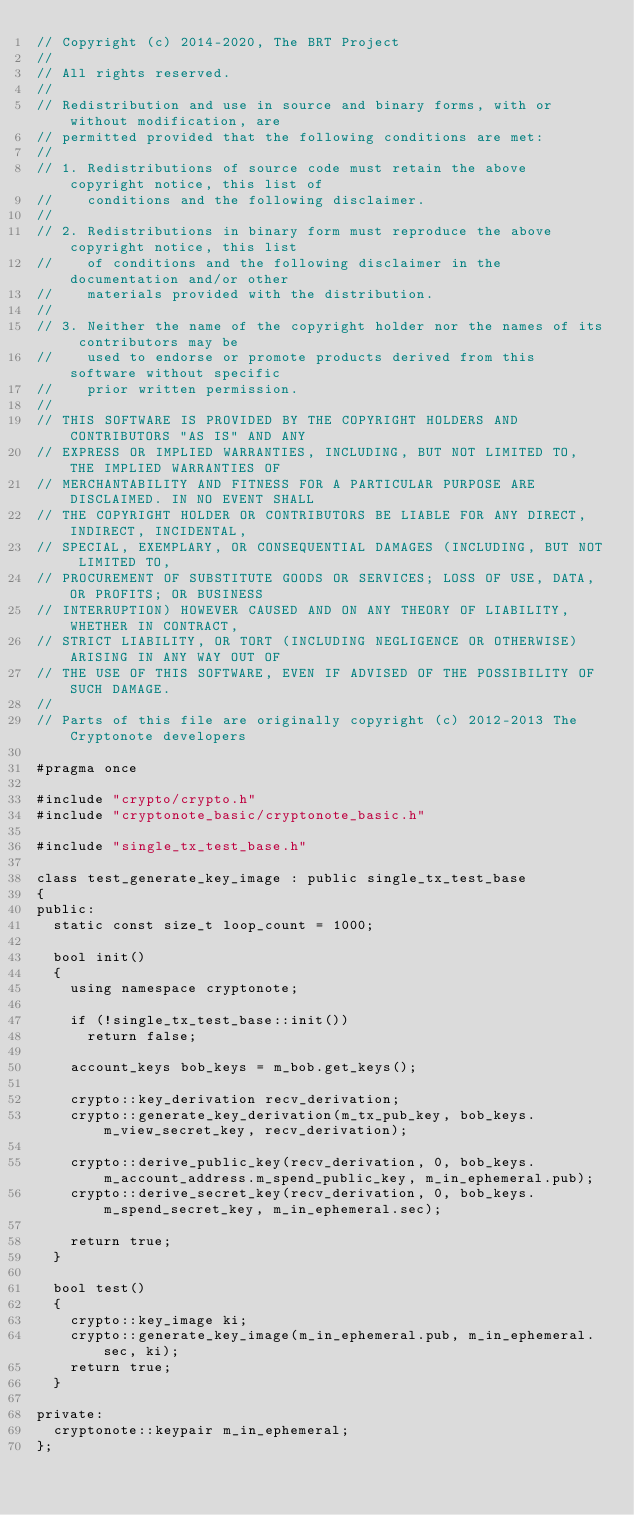<code> <loc_0><loc_0><loc_500><loc_500><_C_>// Copyright (c) 2014-2020, The BRT Project
// 
// All rights reserved.
// 
// Redistribution and use in source and binary forms, with or without modification, are
// permitted provided that the following conditions are met:
// 
// 1. Redistributions of source code must retain the above copyright notice, this list of
//    conditions and the following disclaimer.
// 
// 2. Redistributions in binary form must reproduce the above copyright notice, this list
//    of conditions and the following disclaimer in the documentation and/or other
//    materials provided with the distribution.
// 
// 3. Neither the name of the copyright holder nor the names of its contributors may be
//    used to endorse or promote products derived from this software without specific
//    prior written permission.
// 
// THIS SOFTWARE IS PROVIDED BY THE COPYRIGHT HOLDERS AND CONTRIBUTORS "AS IS" AND ANY
// EXPRESS OR IMPLIED WARRANTIES, INCLUDING, BUT NOT LIMITED TO, THE IMPLIED WARRANTIES OF
// MERCHANTABILITY AND FITNESS FOR A PARTICULAR PURPOSE ARE DISCLAIMED. IN NO EVENT SHALL
// THE COPYRIGHT HOLDER OR CONTRIBUTORS BE LIABLE FOR ANY DIRECT, INDIRECT, INCIDENTAL,
// SPECIAL, EXEMPLARY, OR CONSEQUENTIAL DAMAGES (INCLUDING, BUT NOT LIMITED TO,
// PROCUREMENT OF SUBSTITUTE GOODS OR SERVICES; LOSS OF USE, DATA, OR PROFITS; OR BUSINESS
// INTERRUPTION) HOWEVER CAUSED AND ON ANY THEORY OF LIABILITY, WHETHER IN CONTRACT,
// STRICT LIABILITY, OR TORT (INCLUDING NEGLIGENCE OR OTHERWISE) ARISING IN ANY WAY OUT OF
// THE USE OF THIS SOFTWARE, EVEN IF ADVISED OF THE POSSIBILITY OF SUCH DAMAGE.
// 
// Parts of this file are originally copyright (c) 2012-2013 The Cryptonote developers

#pragma once

#include "crypto/crypto.h"
#include "cryptonote_basic/cryptonote_basic.h"

#include "single_tx_test_base.h"

class test_generate_key_image : public single_tx_test_base
{
public:
  static const size_t loop_count = 1000;

  bool init()
  {
    using namespace cryptonote;

    if (!single_tx_test_base::init())
      return false;

    account_keys bob_keys = m_bob.get_keys();

    crypto::key_derivation recv_derivation;
    crypto::generate_key_derivation(m_tx_pub_key, bob_keys.m_view_secret_key, recv_derivation);

    crypto::derive_public_key(recv_derivation, 0, bob_keys.m_account_address.m_spend_public_key, m_in_ephemeral.pub);
    crypto::derive_secret_key(recv_derivation, 0, bob_keys.m_spend_secret_key, m_in_ephemeral.sec);

    return true;
  }

  bool test()
  {
    crypto::key_image ki;
    crypto::generate_key_image(m_in_ephemeral.pub, m_in_ephemeral.sec, ki);
    return true;
  }

private:
  cryptonote::keypair m_in_ephemeral;
};
</code> 